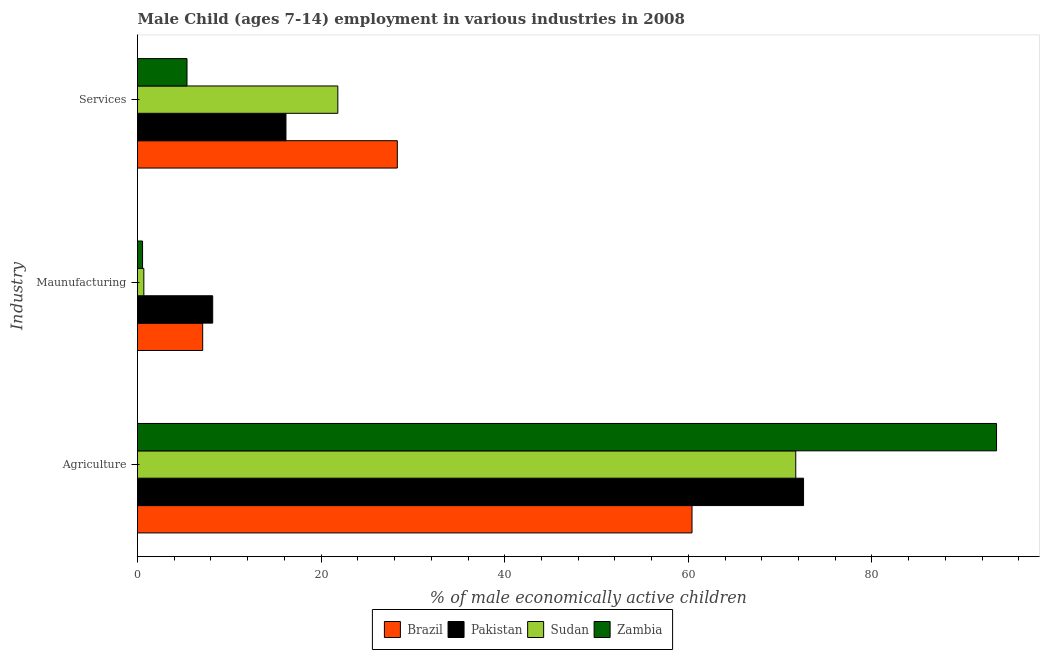How many different coloured bars are there?
Your answer should be compact. 4. What is the label of the 2nd group of bars from the top?
Your answer should be very brief. Maunufacturing. What is the percentage of economically active children in manufacturing in Sudan?
Ensure brevity in your answer.  0.69. Across all countries, what is the maximum percentage of economically active children in agriculture?
Provide a succinct answer. 93.57. Across all countries, what is the minimum percentage of economically active children in agriculture?
Your answer should be very brief. 60.4. In which country was the percentage of economically active children in agriculture minimum?
Provide a succinct answer. Brazil. What is the total percentage of economically active children in services in the graph?
Make the answer very short. 71.68. What is the difference between the percentage of economically active children in services in Brazil and that in Zambia?
Your answer should be compact. 22.91. What is the difference between the percentage of economically active children in manufacturing in Pakistan and the percentage of economically active children in agriculture in Sudan?
Your answer should be very brief. -63.51. What is the average percentage of economically active children in manufacturing per country?
Keep it short and to the point. 4.13. What is the difference between the percentage of economically active children in agriculture and percentage of economically active children in manufacturing in Pakistan?
Ensure brevity in your answer.  64.36. In how many countries, is the percentage of economically active children in manufacturing greater than 40 %?
Your answer should be very brief. 0. What is the ratio of the percentage of economically active children in services in Zambia to that in Brazil?
Give a very brief answer. 0.19. Is the percentage of economically active children in services in Sudan less than that in Zambia?
Provide a succinct answer. No. What is the difference between the highest and the second highest percentage of economically active children in services?
Offer a terse response. 6.48. What is the difference between the highest and the lowest percentage of economically active children in services?
Keep it short and to the point. 22.91. In how many countries, is the percentage of economically active children in agriculture greater than the average percentage of economically active children in agriculture taken over all countries?
Give a very brief answer. 1. Is the sum of the percentage of economically active children in agriculture in Pakistan and Sudan greater than the maximum percentage of economically active children in manufacturing across all countries?
Provide a succinct answer. Yes. What does the 4th bar from the top in Agriculture represents?
Give a very brief answer. Brazil. What does the 4th bar from the bottom in Services represents?
Ensure brevity in your answer.  Zambia. How many bars are there?
Your answer should be very brief. 12. Are all the bars in the graph horizontal?
Your answer should be very brief. Yes. How many countries are there in the graph?
Provide a succinct answer. 4. Are the values on the major ticks of X-axis written in scientific E-notation?
Your response must be concise. No. How many legend labels are there?
Provide a short and direct response. 4. What is the title of the graph?
Provide a short and direct response. Male Child (ages 7-14) employment in various industries in 2008. What is the label or title of the X-axis?
Offer a very short reply. % of male economically active children. What is the label or title of the Y-axis?
Offer a terse response. Industry. What is the % of male economically active children in Brazil in Agriculture?
Make the answer very short. 60.4. What is the % of male economically active children of Pakistan in Agriculture?
Offer a terse response. 72.55. What is the % of male economically active children in Sudan in Agriculture?
Keep it short and to the point. 71.7. What is the % of male economically active children in Zambia in Agriculture?
Provide a short and direct response. 93.57. What is the % of male economically active children in Brazil in Maunufacturing?
Provide a short and direct response. 7.1. What is the % of male economically active children in Pakistan in Maunufacturing?
Your answer should be very brief. 8.19. What is the % of male economically active children of Sudan in Maunufacturing?
Give a very brief answer. 0.69. What is the % of male economically active children of Zambia in Maunufacturing?
Offer a terse response. 0.55. What is the % of male economically active children in Brazil in Services?
Provide a succinct answer. 28.3. What is the % of male economically active children of Pakistan in Services?
Give a very brief answer. 16.17. What is the % of male economically active children in Sudan in Services?
Offer a terse response. 21.82. What is the % of male economically active children of Zambia in Services?
Offer a terse response. 5.39. Across all Industry, what is the maximum % of male economically active children in Brazil?
Your answer should be compact. 60.4. Across all Industry, what is the maximum % of male economically active children in Pakistan?
Provide a short and direct response. 72.55. Across all Industry, what is the maximum % of male economically active children in Sudan?
Ensure brevity in your answer.  71.7. Across all Industry, what is the maximum % of male economically active children in Zambia?
Offer a very short reply. 93.57. Across all Industry, what is the minimum % of male economically active children of Pakistan?
Offer a terse response. 8.19. Across all Industry, what is the minimum % of male economically active children of Sudan?
Provide a short and direct response. 0.69. Across all Industry, what is the minimum % of male economically active children of Zambia?
Ensure brevity in your answer.  0.55. What is the total % of male economically active children of Brazil in the graph?
Your response must be concise. 95.8. What is the total % of male economically active children of Pakistan in the graph?
Your answer should be compact. 96.91. What is the total % of male economically active children in Sudan in the graph?
Make the answer very short. 94.21. What is the total % of male economically active children of Zambia in the graph?
Provide a succinct answer. 99.51. What is the difference between the % of male economically active children of Brazil in Agriculture and that in Maunufacturing?
Your answer should be very brief. 53.3. What is the difference between the % of male economically active children in Pakistan in Agriculture and that in Maunufacturing?
Offer a terse response. 64.36. What is the difference between the % of male economically active children of Sudan in Agriculture and that in Maunufacturing?
Ensure brevity in your answer.  71.01. What is the difference between the % of male economically active children in Zambia in Agriculture and that in Maunufacturing?
Offer a terse response. 93.02. What is the difference between the % of male economically active children of Brazil in Agriculture and that in Services?
Your response must be concise. 32.1. What is the difference between the % of male economically active children of Pakistan in Agriculture and that in Services?
Ensure brevity in your answer.  56.38. What is the difference between the % of male economically active children in Sudan in Agriculture and that in Services?
Your answer should be very brief. 49.88. What is the difference between the % of male economically active children of Zambia in Agriculture and that in Services?
Your answer should be compact. 88.18. What is the difference between the % of male economically active children in Brazil in Maunufacturing and that in Services?
Ensure brevity in your answer.  -21.2. What is the difference between the % of male economically active children of Pakistan in Maunufacturing and that in Services?
Provide a short and direct response. -7.98. What is the difference between the % of male economically active children of Sudan in Maunufacturing and that in Services?
Your answer should be compact. -21.13. What is the difference between the % of male economically active children in Zambia in Maunufacturing and that in Services?
Your answer should be compact. -4.84. What is the difference between the % of male economically active children in Brazil in Agriculture and the % of male economically active children in Pakistan in Maunufacturing?
Ensure brevity in your answer.  52.21. What is the difference between the % of male economically active children of Brazil in Agriculture and the % of male economically active children of Sudan in Maunufacturing?
Provide a short and direct response. 59.71. What is the difference between the % of male economically active children in Brazil in Agriculture and the % of male economically active children in Zambia in Maunufacturing?
Ensure brevity in your answer.  59.85. What is the difference between the % of male economically active children of Pakistan in Agriculture and the % of male economically active children of Sudan in Maunufacturing?
Offer a terse response. 71.86. What is the difference between the % of male economically active children in Pakistan in Agriculture and the % of male economically active children in Zambia in Maunufacturing?
Ensure brevity in your answer.  72. What is the difference between the % of male economically active children of Sudan in Agriculture and the % of male economically active children of Zambia in Maunufacturing?
Keep it short and to the point. 71.15. What is the difference between the % of male economically active children of Brazil in Agriculture and the % of male economically active children of Pakistan in Services?
Offer a terse response. 44.23. What is the difference between the % of male economically active children of Brazil in Agriculture and the % of male economically active children of Sudan in Services?
Your response must be concise. 38.58. What is the difference between the % of male economically active children in Brazil in Agriculture and the % of male economically active children in Zambia in Services?
Provide a short and direct response. 55.01. What is the difference between the % of male economically active children of Pakistan in Agriculture and the % of male economically active children of Sudan in Services?
Keep it short and to the point. 50.73. What is the difference between the % of male economically active children in Pakistan in Agriculture and the % of male economically active children in Zambia in Services?
Ensure brevity in your answer.  67.16. What is the difference between the % of male economically active children in Sudan in Agriculture and the % of male economically active children in Zambia in Services?
Your response must be concise. 66.31. What is the difference between the % of male economically active children in Brazil in Maunufacturing and the % of male economically active children in Pakistan in Services?
Your answer should be compact. -9.07. What is the difference between the % of male economically active children in Brazil in Maunufacturing and the % of male economically active children in Sudan in Services?
Offer a very short reply. -14.72. What is the difference between the % of male economically active children in Brazil in Maunufacturing and the % of male economically active children in Zambia in Services?
Provide a short and direct response. 1.71. What is the difference between the % of male economically active children in Pakistan in Maunufacturing and the % of male economically active children in Sudan in Services?
Give a very brief answer. -13.63. What is the average % of male economically active children of Brazil per Industry?
Your answer should be very brief. 31.93. What is the average % of male economically active children of Pakistan per Industry?
Offer a very short reply. 32.3. What is the average % of male economically active children of Sudan per Industry?
Provide a short and direct response. 31.4. What is the average % of male economically active children in Zambia per Industry?
Offer a terse response. 33.17. What is the difference between the % of male economically active children of Brazil and % of male economically active children of Pakistan in Agriculture?
Ensure brevity in your answer.  -12.15. What is the difference between the % of male economically active children in Brazil and % of male economically active children in Zambia in Agriculture?
Provide a short and direct response. -33.17. What is the difference between the % of male economically active children in Pakistan and % of male economically active children in Sudan in Agriculture?
Offer a terse response. 0.85. What is the difference between the % of male economically active children of Pakistan and % of male economically active children of Zambia in Agriculture?
Offer a terse response. -21.02. What is the difference between the % of male economically active children in Sudan and % of male economically active children in Zambia in Agriculture?
Offer a very short reply. -21.87. What is the difference between the % of male economically active children of Brazil and % of male economically active children of Pakistan in Maunufacturing?
Provide a succinct answer. -1.09. What is the difference between the % of male economically active children in Brazil and % of male economically active children in Sudan in Maunufacturing?
Provide a succinct answer. 6.41. What is the difference between the % of male economically active children of Brazil and % of male economically active children of Zambia in Maunufacturing?
Give a very brief answer. 6.55. What is the difference between the % of male economically active children of Pakistan and % of male economically active children of Sudan in Maunufacturing?
Give a very brief answer. 7.5. What is the difference between the % of male economically active children in Pakistan and % of male economically active children in Zambia in Maunufacturing?
Provide a succinct answer. 7.64. What is the difference between the % of male economically active children of Sudan and % of male economically active children of Zambia in Maunufacturing?
Keep it short and to the point. 0.14. What is the difference between the % of male economically active children of Brazil and % of male economically active children of Pakistan in Services?
Keep it short and to the point. 12.13. What is the difference between the % of male economically active children of Brazil and % of male economically active children of Sudan in Services?
Your response must be concise. 6.48. What is the difference between the % of male economically active children of Brazil and % of male economically active children of Zambia in Services?
Ensure brevity in your answer.  22.91. What is the difference between the % of male economically active children in Pakistan and % of male economically active children in Sudan in Services?
Your answer should be very brief. -5.65. What is the difference between the % of male economically active children in Pakistan and % of male economically active children in Zambia in Services?
Ensure brevity in your answer.  10.78. What is the difference between the % of male economically active children of Sudan and % of male economically active children of Zambia in Services?
Provide a succinct answer. 16.43. What is the ratio of the % of male economically active children in Brazil in Agriculture to that in Maunufacturing?
Provide a succinct answer. 8.51. What is the ratio of the % of male economically active children in Pakistan in Agriculture to that in Maunufacturing?
Provide a short and direct response. 8.86. What is the ratio of the % of male economically active children of Sudan in Agriculture to that in Maunufacturing?
Provide a succinct answer. 103.91. What is the ratio of the % of male economically active children in Zambia in Agriculture to that in Maunufacturing?
Your answer should be compact. 170.13. What is the ratio of the % of male economically active children in Brazil in Agriculture to that in Services?
Keep it short and to the point. 2.13. What is the ratio of the % of male economically active children in Pakistan in Agriculture to that in Services?
Provide a short and direct response. 4.49. What is the ratio of the % of male economically active children in Sudan in Agriculture to that in Services?
Provide a succinct answer. 3.29. What is the ratio of the % of male economically active children of Zambia in Agriculture to that in Services?
Your response must be concise. 17.36. What is the ratio of the % of male economically active children of Brazil in Maunufacturing to that in Services?
Your answer should be compact. 0.25. What is the ratio of the % of male economically active children of Pakistan in Maunufacturing to that in Services?
Offer a terse response. 0.51. What is the ratio of the % of male economically active children in Sudan in Maunufacturing to that in Services?
Your response must be concise. 0.03. What is the ratio of the % of male economically active children of Zambia in Maunufacturing to that in Services?
Provide a short and direct response. 0.1. What is the difference between the highest and the second highest % of male economically active children in Brazil?
Keep it short and to the point. 32.1. What is the difference between the highest and the second highest % of male economically active children of Pakistan?
Offer a terse response. 56.38. What is the difference between the highest and the second highest % of male economically active children of Sudan?
Your answer should be compact. 49.88. What is the difference between the highest and the second highest % of male economically active children of Zambia?
Offer a very short reply. 88.18. What is the difference between the highest and the lowest % of male economically active children in Brazil?
Offer a very short reply. 53.3. What is the difference between the highest and the lowest % of male economically active children in Pakistan?
Provide a succinct answer. 64.36. What is the difference between the highest and the lowest % of male economically active children in Sudan?
Keep it short and to the point. 71.01. What is the difference between the highest and the lowest % of male economically active children of Zambia?
Ensure brevity in your answer.  93.02. 